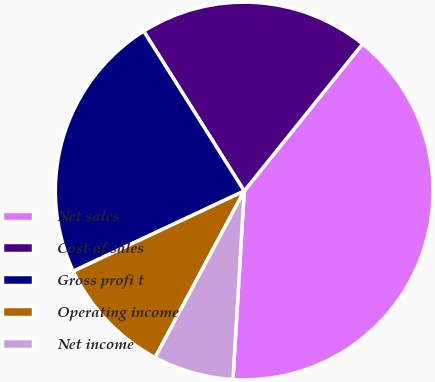Convert chart. <chart><loc_0><loc_0><loc_500><loc_500><pie_chart><fcel>Net sales<fcel>Cost of sales<fcel>Gross profi t<fcel>Operating income<fcel>Net income<nl><fcel>40.17%<fcel>19.72%<fcel>23.05%<fcel>10.2%<fcel>6.87%<nl></chart> 